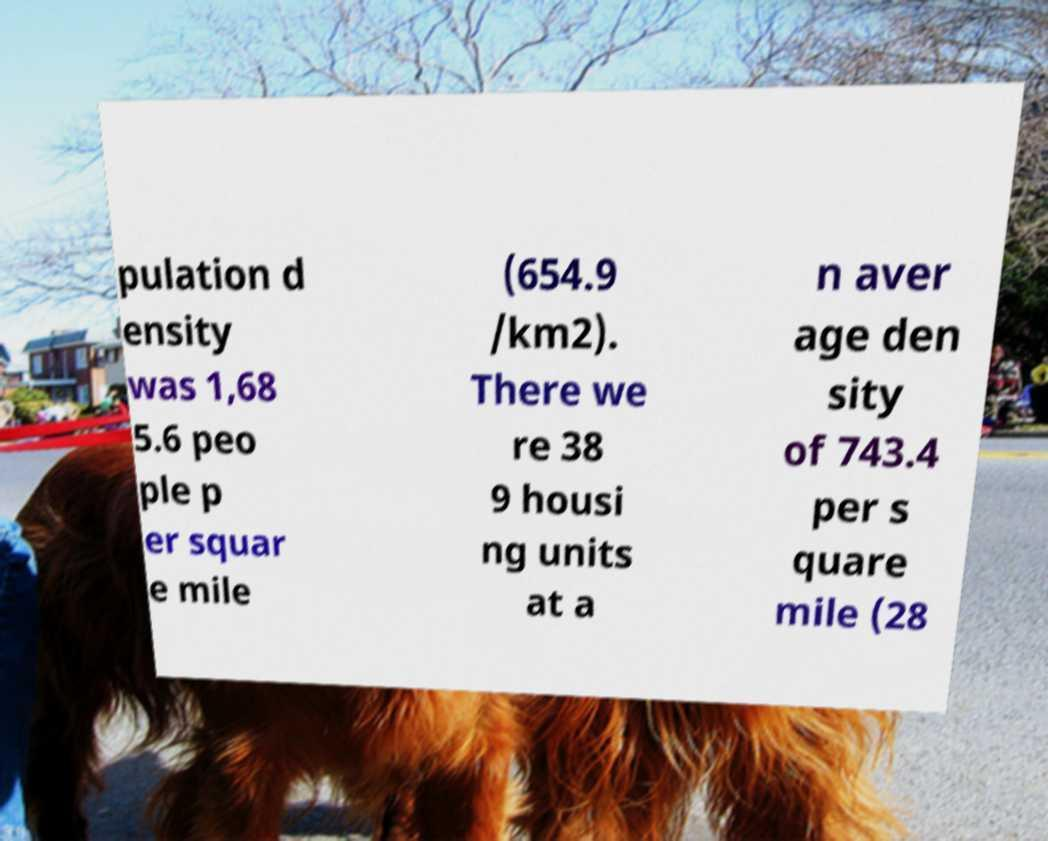Can you read and provide the text displayed in the image?This photo seems to have some interesting text. Can you extract and type it out for me? pulation d ensity was 1,68 5.6 peo ple p er squar e mile (654.9 /km2). There we re 38 9 housi ng units at a n aver age den sity of 743.4 per s quare mile (28 